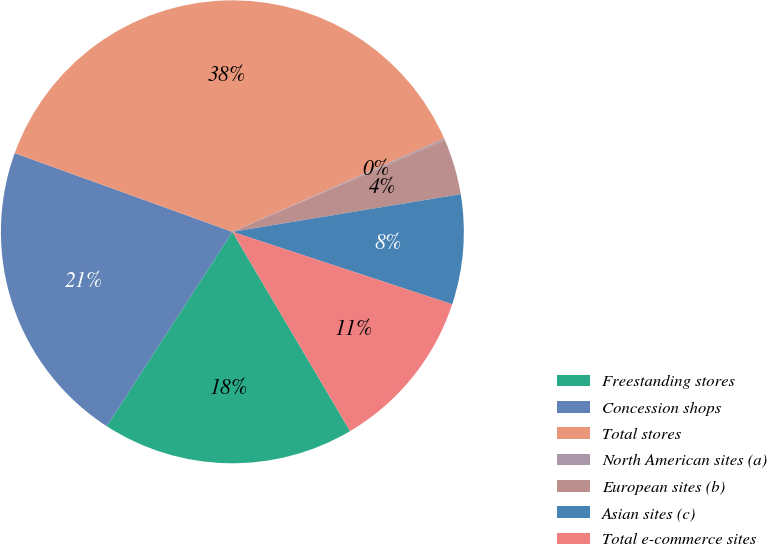<chart> <loc_0><loc_0><loc_500><loc_500><pie_chart><fcel>Freestanding stores<fcel>Concession shops<fcel>Total stores<fcel>North American sites (a)<fcel>European sites (b)<fcel>Asian sites (c)<fcel>Total e-commerce sites<nl><fcel>17.62%<fcel>21.39%<fcel>37.88%<fcel>0.11%<fcel>3.89%<fcel>7.67%<fcel>11.44%<nl></chart> 